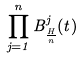<formula> <loc_0><loc_0><loc_500><loc_500>\prod _ { j = 1 } ^ { n } B ^ { j } _ { \frac { H } { n } } ( t )</formula> 